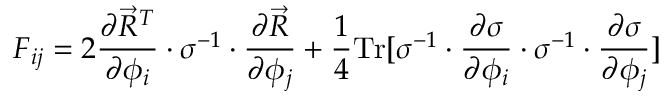<formula> <loc_0><loc_0><loc_500><loc_500>F _ { i j } = 2 \frac { \partial \vec { R } ^ { T } } { \partial \phi _ { i } } \cdot \sigma ^ { - 1 } \cdot \frac { \partial \vec { R } } { \partial \phi _ { j } } + \frac { 1 } { 4 } T r [ \sigma ^ { - 1 } \cdot \frac { \partial \sigma } { \partial \phi _ { i } } \cdot \sigma ^ { - 1 } \cdot \frac { \partial \sigma } { \partial \phi _ { j } } ]</formula> 